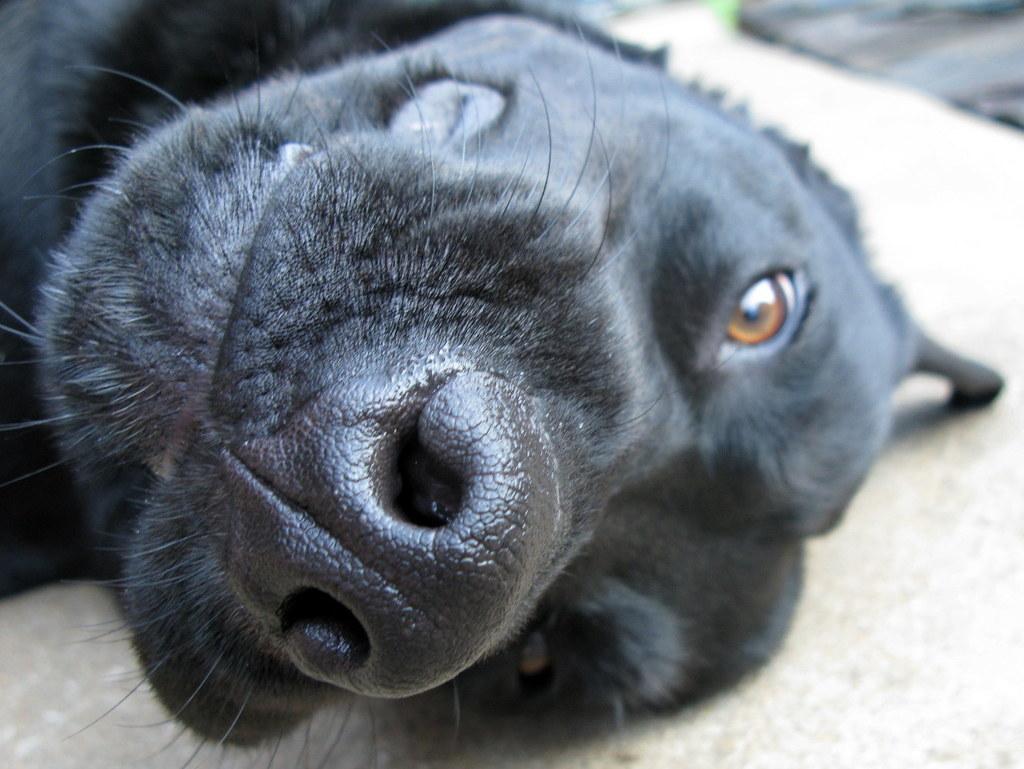Can you describe this image briefly? In this picture we can see black dog on the surface. In the background of the image it is blurry. 